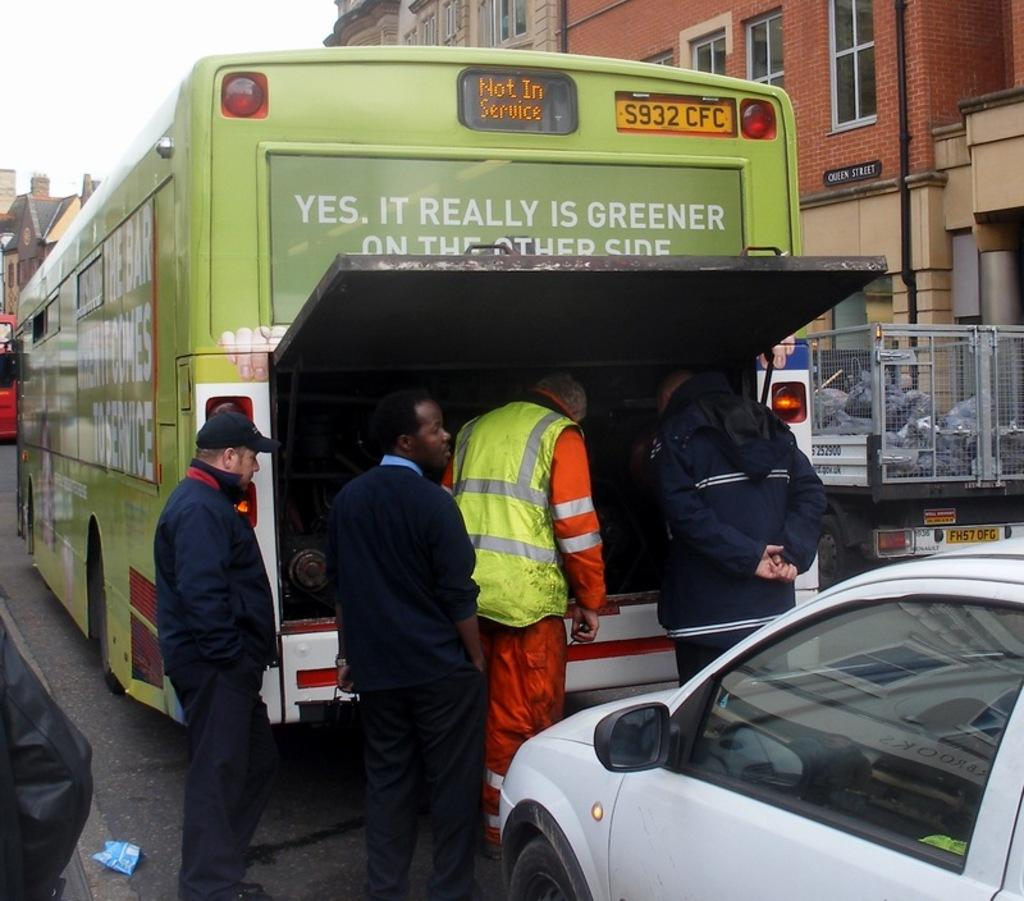<image>
Write a terse but informative summary of the picture. A green bus says that it is currently not in service. 